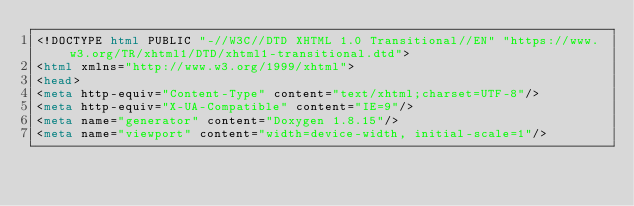<code> <loc_0><loc_0><loc_500><loc_500><_HTML_><!DOCTYPE html PUBLIC "-//W3C//DTD XHTML 1.0 Transitional//EN" "https://www.w3.org/TR/xhtml1/DTD/xhtml1-transitional.dtd">
<html xmlns="http://www.w3.org/1999/xhtml">
<head>
<meta http-equiv="Content-Type" content="text/xhtml;charset=UTF-8"/>
<meta http-equiv="X-UA-Compatible" content="IE=9"/>
<meta name="generator" content="Doxygen 1.8.15"/>
<meta name="viewport" content="width=device-width, initial-scale=1"/></code> 